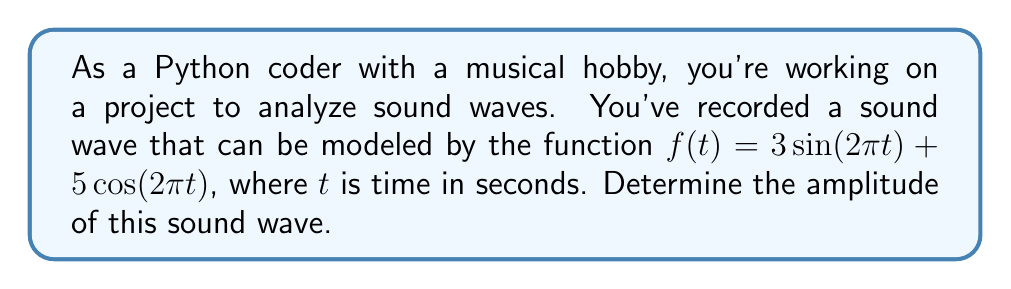Could you help me with this problem? To find the amplitude of this sound wave, we need to follow these steps:

1) The given function is in the form $f(t) = a\sin(\omega t) + b\cos(\omega t)$, where $a = 3$, $b = 5$, and $\omega = 2\pi$.

2) This can be rewritten in the standard form $A\sin(\omega t + \phi)$, where $A$ is the amplitude we're looking for.

3) The amplitude $A$ is related to $a$ and $b$ by the formula:

   $$A = \sqrt{a^2 + b^2}$$

4) Substituting our values:

   $$A = \sqrt{3^2 + 5^2}$$

5) Simplify:
   
   $$A = \sqrt{9 + 25} = \sqrt{34}$$

6) The square root of 34 cannot be simplified further, so this is our final answer.

In Python, you could calculate this as:

```python
import math

a, b = 3, 5
amplitude = math.sqrt(a**2 + b**2)
print(f"The amplitude is {amplitude}")
```

This would output: "The amplitude is 5.830951894845301"
Answer: The amplitude of the sound wave is $\sqrt{34}$ (approximately 5.83). 